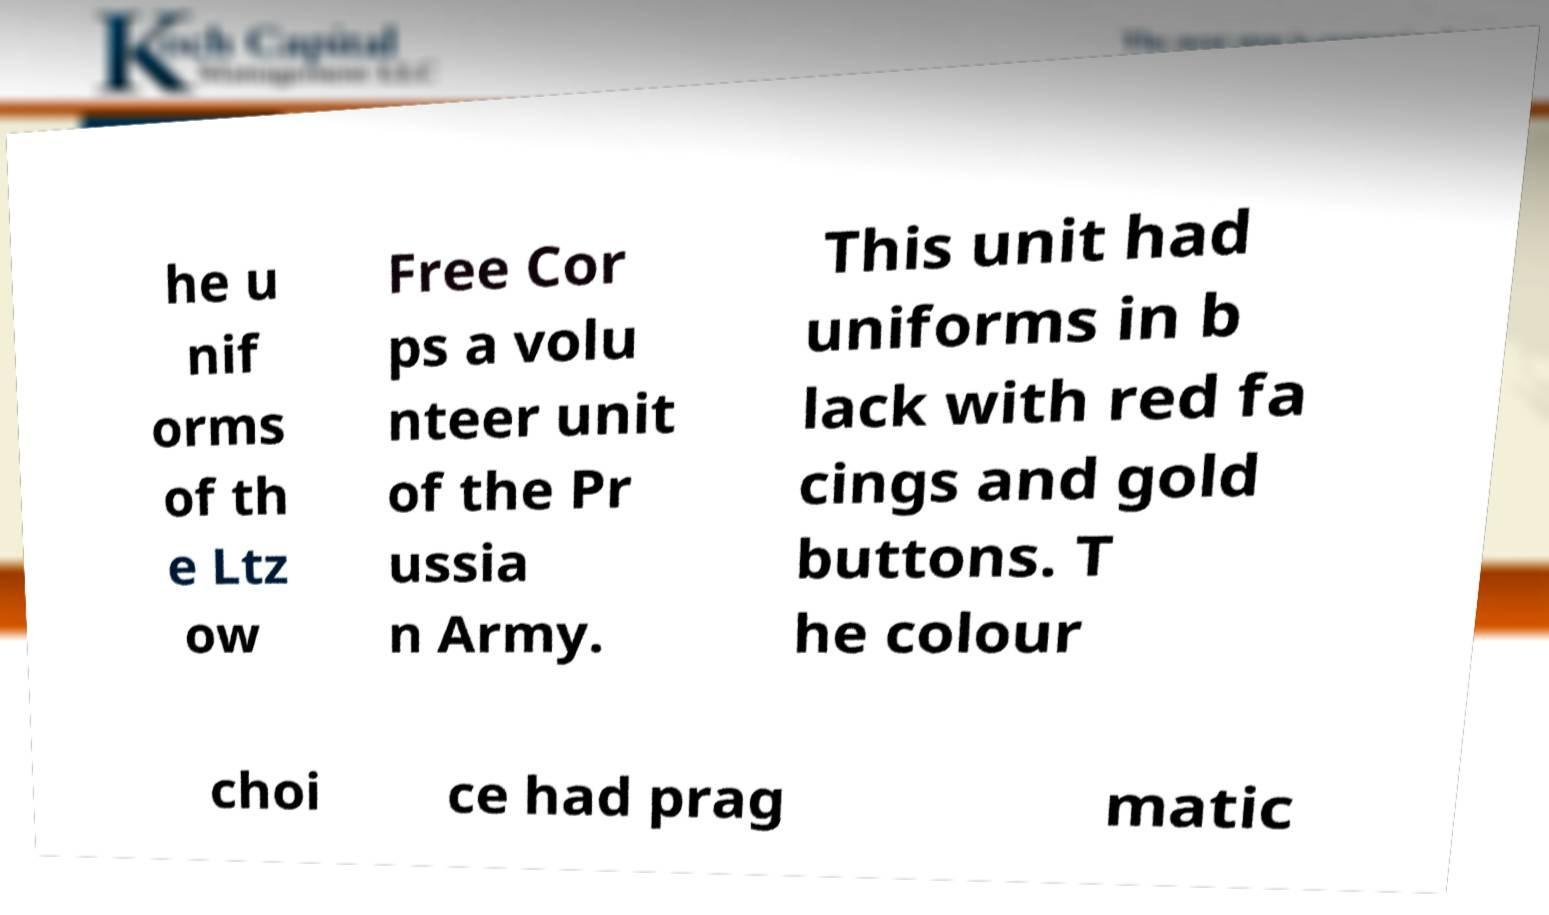There's text embedded in this image that I need extracted. Can you transcribe it verbatim? he u nif orms of th e Ltz ow Free Cor ps a volu nteer unit of the Pr ussia n Army. This unit had uniforms in b lack with red fa cings and gold buttons. T he colour choi ce had prag matic 